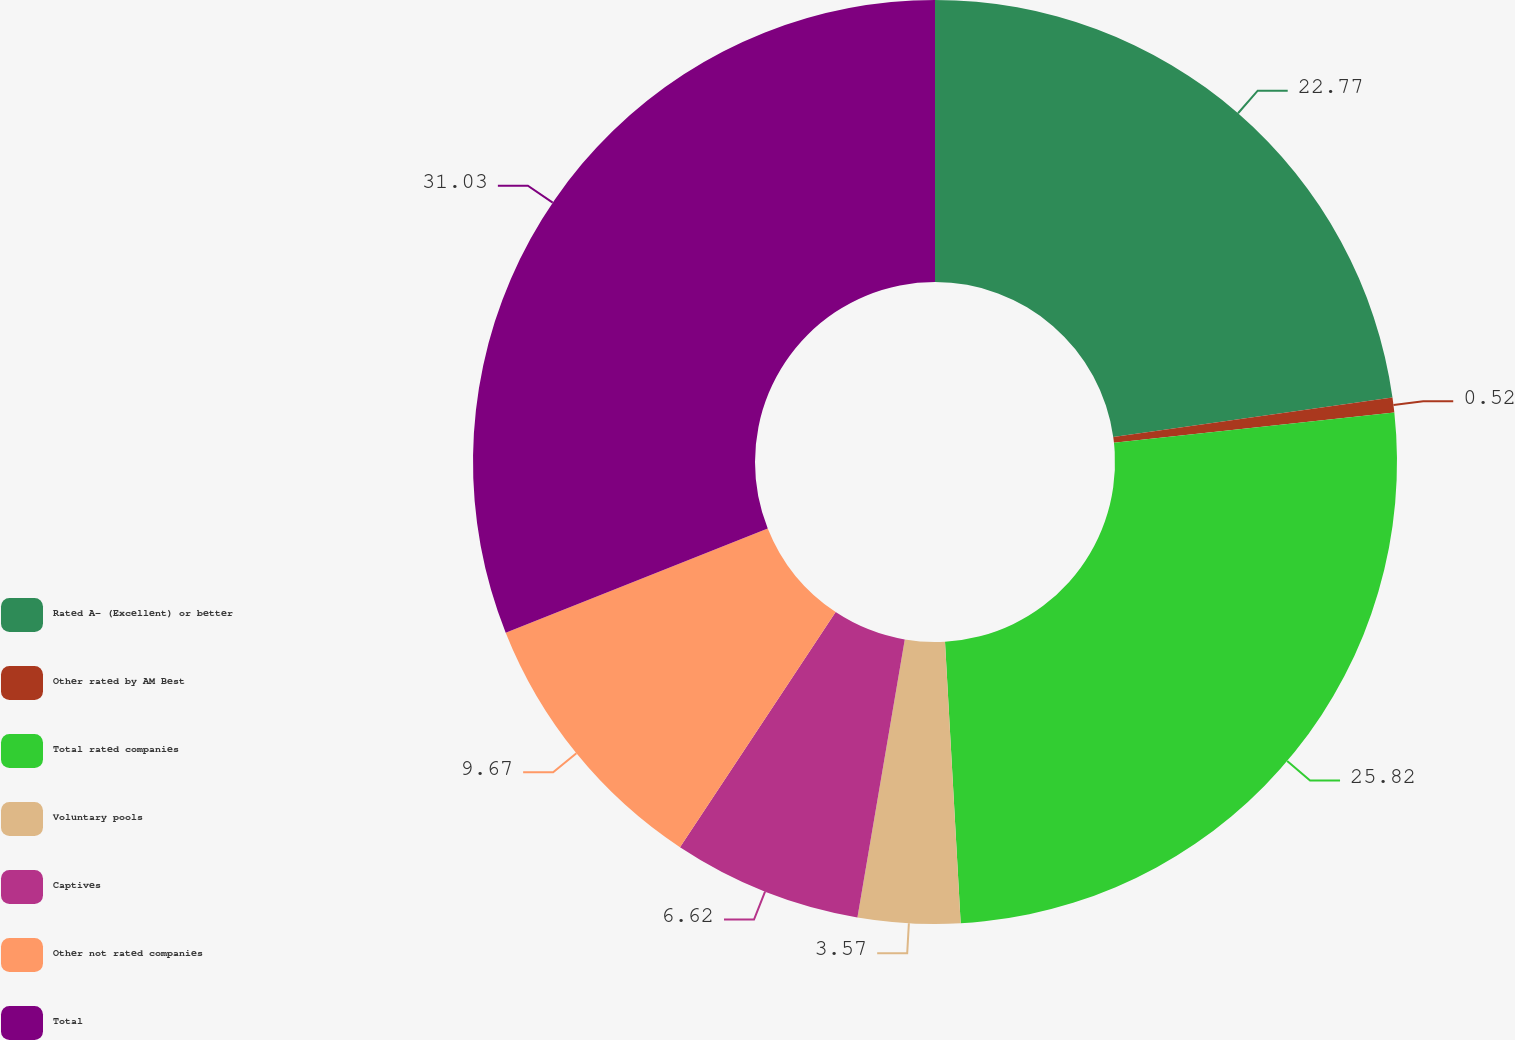Convert chart. <chart><loc_0><loc_0><loc_500><loc_500><pie_chart><fcel>Rated A- (Excellent) or better<fcel>Other rated by AM Best<fcel>Total rated companies<fcel>Voluntary pools<fcel>Captives<fcel>Other not rated companies<fcel>Total<nl><fcel>22.77%<fcel>0.52%<fcel>25.82%<fcel>3.57%<fcel>6.62%<fcel>9.67%<fcel>31.02%<nl></chart> 